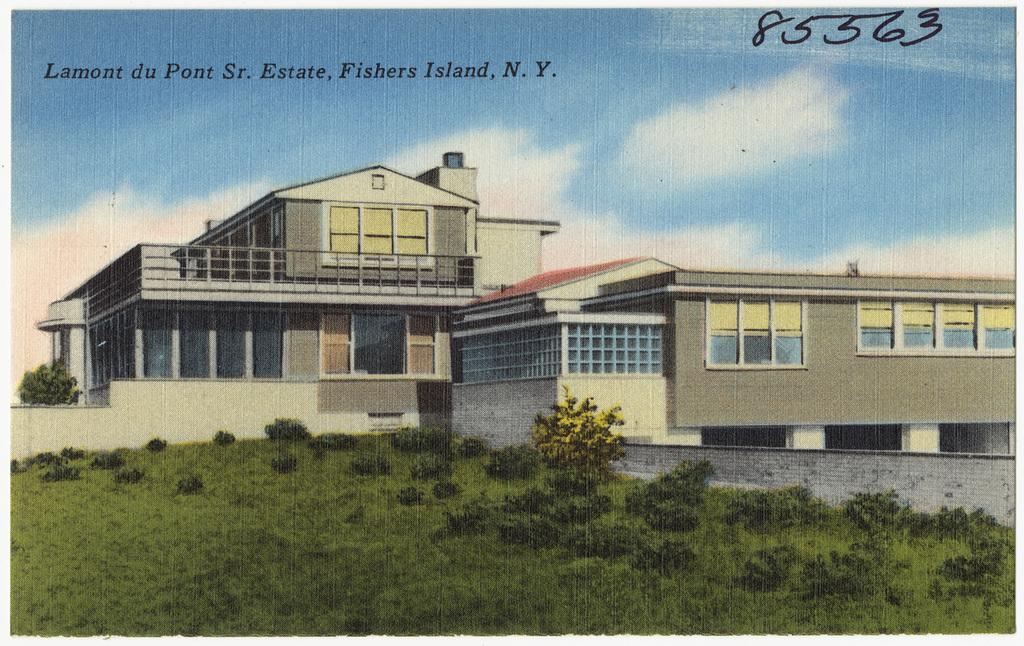What type of surface is on the ground in the image? There is grass on the ground in the image. What other natural elements can be seen in the image? There are plants in the image. What man-made structures are present in the image? There is a wall and buildings in the image. What can be seen in the distance in the image? The sky is visible in the background of the image. What letter does the grandfather write in the image? There is no grandfather or letter present in the image. 